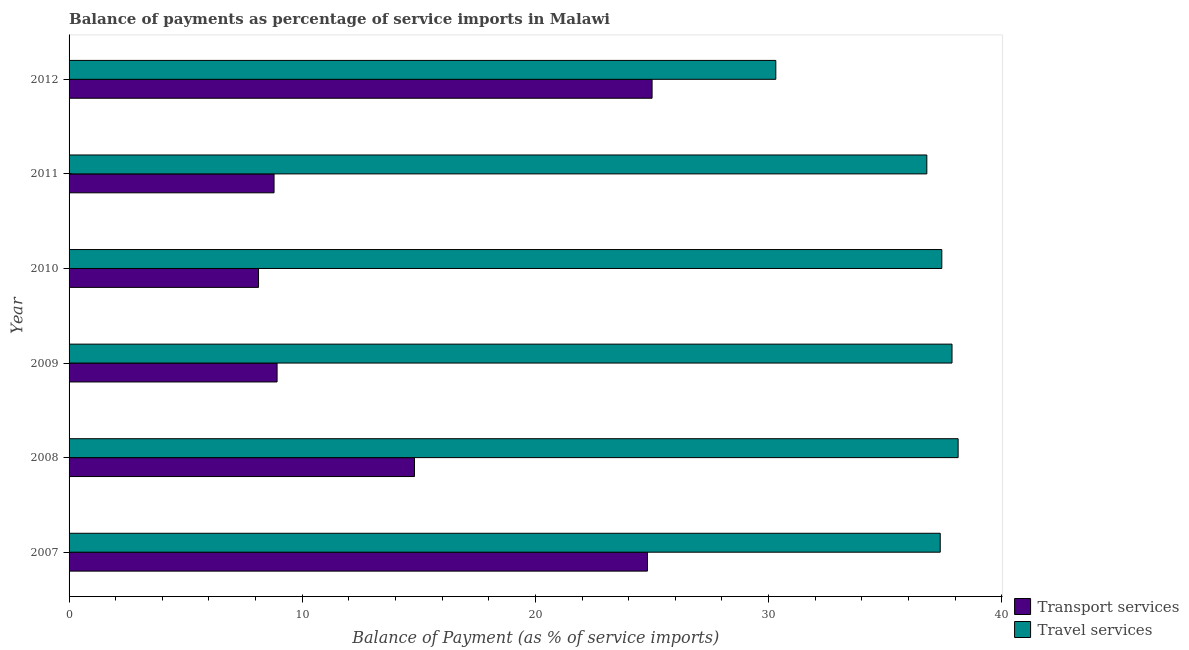How many groups of bars are there?
Your response must be concise. 6. Are the number of bars on each tick of the Y-axis equal?
Your answer should be compact. Yes. In how many cases, is the number of bars for a given year not equal to the number of legend labels?
Provide a short and direct response. 0. What is the balance of payments of transport services in 2011?
Your answer should be very brief. 8.79. Across all years, what is the maximum balance of payments of transport services?
Provide a short and direct response. 25. Across all years, what is the minimum balance of payments of transport services?
Offer a very short reply. 8.13. In which year was the balance of payments of travel services maximum?
Make the answer very short. 2008. In which year was the balance of payments of travel services minimum?
Your response must be concise. 2012. What is the total balance of payments of transport services in the graph?
Give a very brief answer. 90.46. What is the difference between the balance of payments of transport services in 2011 and the balance of payments of travel services in 2007?
Your answer should be very brief. -28.57. What is the average balance of payments of travel services per year?
Keep it short and to the point. 36.31. In the year 2010, what is the difference between the balance of payments of transport services and balance of payments of travel services?
Your answer should be very brief. -29.3. Is the difference between the balance of payments of travel services in 2008 and 2011 greater than the difference between the balance of payments of transport services in 2008 and 2011?
Provide a short and direct response. No. What is the difference between the highest and the second highest balance of payments of travel services?
Offer a very short reply. 0.26. What is the difference between the highest and the lowest balance of payments of transport services?
Provide a succinct answer. 16.88. In how many years, is the balance of payments of travel services greater than the average balance of payments of travel services taken over all years?
Keep it short and to the point. 5. Is the sum of the balance of payments of transport services in 2007 and 2010 greater than the maximum balance of payments of travel services across all years?
Provide a succinct answer. No. What does the 2nd bar from the top in 2009 represents?
Your response must be concise. Transport services. What does the 1st bar from the bottom in 2009 represents?
Your answer should be very brief. Transport services. What is the difference between two consecutive major ticks on the X-axis?
Provide a short and direct response. 10. Does the graph contain any zero values?
Provide a succinct answer. No. Where does the legend appear in the graph?
Your answer should be very brief. Bottom right. What is the title of the graph?
Provide a short and direct response. Balance of payments as percentage of service imports in Malawi. What is the label or title of the X-axis?
Provide a succinct answer. Balance of Payment (as % of service imports). What is the Balance of Payment (as % of service imports) of Transport services in 2007?
Make the answer very short. 24.81. What is the Balance of Payment (as % of service imports) in Travel services in 2007?
Your response must be concise. 37.36. What is the Balance of Payment (as % of service imports) in Transport services in 2008?
Your answer should be compact. 14.81. What is the Balance of Payment (as % of service imports) of Travel services in 2008?
Your answer should be compact. 38.13. What is the Balance of Payment (as % of service imports) in Transport services in 2009?
Offer a very short reply. 8.92. What is the Balance of Payment (as % of service imports) of Travel services in 2009?
Make the answer very short. 37.87. What is the Balance of Payment (as % of service imports) in Transport services in 2010?
Ensure brevity in your answer.  8.13. What is the Balance of Payment (as % of service imports) of Travel services in 2010?
Keep it short and to the point. 37.43. What is the Balance of Payment (as % of service imports) of Transport services in 2011?
Provide a succinct answer. 8.79. What is the Balance of Payment (as % of service imports) in Travel services in 2011?
Give a very brief answer. 36.79. What is the Balance of Payment (as % of service imports) in Transport services in 2012?
Make the answer very short. 25. What is the Balance of Payment (as % of service imports) in Travel services in 2012?
Your response must be concise. 30.31. Across all years, what is the maximum Balance of Payment (as % of service imports) of Transport services?
Ensure brevity in your answer.  25. Across all years, what is the maximum Balance of Payment (as % of service imports) in Travel services?
Offer a terse response. 38.13. Across all years, what is the minimum Balance of Payment (as % of service imports) in Transport services?
Give a very brief answer. 8.13. Across all years, what is the minimum Balance of Payment (as % of service imports) in Travel services?
Keep it short and to the point. 30.31. What is the total Balance of Payment (as % of service imports) in Transport services in the graph?
Offer a very short reply. 90.46. What is the total Balance of Payment (as % of service imports) of Travel services in the graph?
Give a very brief answer. 217.89. What is the difference between the Balance of Payment (as % of service imports) of Transport services in 2007 and that in 2008?
Your answer should be very brief. 9.99. What is the difference between the Balance of Payment (as % of service imports) of Travel services in 2007 and that in 2008?
Keep it short and to the point. -0.77. What is the difference between the Balance of Payment (as % of service imports) of Transport services in 2007 and that in 2009?
Offer a very short reply. 15.88. What is the difference between the Balance of Payment (as % of service imports) in Travel services in 2007 and that in 2009?
Your answer should be very brief. -0.51. What is the difference between the Balance of Payment (as % of service imports) in Transport services in 2007 and that in 2010?
Offer a very short reply. 16.68. What is the difference between the Balance of Payment (as % of service imports) of Travel services in 2007 and that in 2010?
Your answer should be very brief. -0.07. What is the difference between the Balance of Payment (as % of service imports) of Transport services in 2007 and that in 2011?
Offer a very short reply. 16.01. What is the difference between the Balance of Payment (as % of service imports) of Travel services in 2007 and that in 2011?
Provide a succinct answer. 0.58. What is the difference between the Balance of Payment (as % of service imports) of Transport services in 2007 and that in 2012?
Your answer should be compact. -0.2. What is the difference between the Balance of Payment (as % of service imports) in Travel services in 2007 and that in 2012?
Your response must be concise. 7.05. What is the difference between the Balance of Payment (as % of service imports) of Transport services in 2008 and that in 2009?
Provide a short and direct response. 5.89. What is the difference between the Balance of Payment (as % of service imports) of Travel services in 2008 and that in 2009?
Offer a terse response. 0.26. What is the difference between the Balance of Payment (as % of service imports) in Transport services in 2008 and that in 2010?
Ensure brevity in your answer.  6.69. What is the difference between the Balance of Payment (as % of service imports) of Travel services in 2008 and that in 2010?
Offer a very short reply. 0.7. What is the difference between the Balance of Payment (as % of service imports) of Transport services in 2008 and that in 2011?
Make the answer very short. 6.02. What is the difference between the Balance of Payment (as % of service imports) in Travel services in 2008 and that in 2011?
Give a very brief answer. 1.34. What is the difference between the Balance of Payment (as % of service imports) of Transport services in 2008 and that in 2012?
Your response must be concise. -10.19. What is the difference between the Balance of Payment (as % of service imports) of Travel services in 2008 and that in 2012?
Offer a terse response. 7.82. What is the difference between the Balance of Payment (as % of service imports) of Transport services in 2009 and that in 2010?
Provide a succinct answer. 0.8. What is the difference between the Balance of Payment (as % of service imports) of Travel services in 2009 and that in 2010?
Offer a very short reply. 0.44. What is the difference between the Balance of Payment (as % of service imports) of Transport services in 2009 and that in 2011?
Ensure brevity in your answer.  0.13. What is the difference between the Balance of Payment (as % of service imports) in Travel services in 2009 and that in 2011?
Offer a very short reply. 1.08. What is the difference between the Balance of Payment (as % of service imports) of Transport services in 2009 and that in 2012?
Make the answer very short. -16.08. What is the difference between the Balance of Payment (as % of service imports) of Travel services in 2009 and that in 2012?
Give a very brief answer. 7.56. What is the difference between the Balance of Payment (as % of service imports) of Transport services in 2010 and that in 2011?
Make the answer very short. -0.67. What is the difference between the Balance of Payment (as % of service imports) in Travel services in 2010 and that in 2011?
Your answer should be compact. 0.64. What is the difference between the Balance of Payment (as % of service imports) in Transport services in 2010 and that in 2012?
Keep it short and to the point. -16.88. What is the difference between the Balance of Payment (as % of service imports) in Travel services in 2010 and that in 2012?
Give a very brief answer. 7.12. What is the difference between the Balance of Payment (as % of service imports) of Transport services in 2011 and that in 2012?
Give a very brief answer. -16.21. What is the difference between the Balance of Payment (as % of service imports) of Travel services in 2011 and that in 2012?
Ensure brevity in your answer.  6.48. What is the difference between the Balance of Payment (as % of service imports) of Transport services in 2007 and the Balance of Payment (as % of service imports) of Travel services in 2008?
Offer a very short reply. -13.32. What is the difference between the Balance of Payment (as % of service imports) in Transport services in 2007 and the Balance of Payment (as % of service imports) in Travel services in 2009?
Provide a succinct answer. -13.06. What is the difference between the Balance of Payment (as % of service imports) in Transport services in 2007 and the Balance of Payment (as % of service imports) in Travel services in 2010?
Provide a succinct answer. -12.62. What is the difference between the Balance of Payment (as % of service imports) of Transport services in 2007 and the Balance of Payment (as % of service imports) of Travel services in 2011?
Offer a terse response. -11.98. What is the difference between the Balance of Payment (as % of service imports) in Transport services in 2007 and the Balance of Payment (as % of service imports) in Travel services in 2012?
Ensure brevity in your answer.  -5.51. What is the difference between the Balance of Payment (as % of service imports) in Transport services in 2008 and the Balance of Payment (as % of service imports) in Travel services in 2009?
Your response must be concise. -23.05. What is the difference between the Balance of Payment (as % of service imports) in Transport services in 2008 and the Balance of Payment (as % of service imports) in Travel services in 2010?
Keep it short and to the point. -22.62. What is the difference between the Balance of Payment (as % of service imports) in Transport services in 2008 and the Balance of Payment (as % of service imports) in Travel services in 2011?
Give a very brief answer. -21.97. What is the difference between the Balance of Payment (as % of service imports) of Transport services in 2008 and the Balance of Payment (as % of service imports) of Travel services in 2012?
Keep it short and to the point. -15.5. What is the difference between the Balance of Payment (as % of service imports) in Transport services in 2009 and the Balance of Payment (as % of service imports) in Travel services in 2010?
Provide a succinct answer. -28.51. What is the difference between the Balance of Payment (as % of service imports) in Transport services in 2009 and the Balance of Payment (as % of service imports) in Travel services in 2011?
Provide a succinct answer. -27.87. What is the difference between the Balance of Payment (as % of service imports) of Transport services in 2009 and the Balance of Payment (as % of service imports) of Travel services in 2012?
Offer a terse response. -21.39. What is the difference between the Balance of Payment (as % of service imports) of Transport services in 2010 and the Balance of Payment (as % of service imports) of Travel services in 2011?
Give a very brief answer. -28.66. What is the difference between the Balance of Payment (as % of service imports) in Transport services in 2010 and the Balance of Payment (as % of service imports) in Travel services in 2012?
Ensure brevity in your answer.  -22.19. What is the difference between the Balance of Payment (as % of service imports) of Transport services in 2011 and the Balance of Payment (as % of service imports) of Travel services in 2012?
Offer a terse response. -21.52. What is the average Balance of Payment (as % of service imports) in Transport services per year?
Offer a very short reply. 15.08. What is the average Balance of Payment (as % of service imports) of Travel services per year?
Give a very brief answer. 36.31. In the year 2007, what is the difference between the Balance of Payment (as % of service imports) of Transport services and Balance of Payment (as % of service imports) of Travel services?
Your answer should be very brief. -12.56. In the year 2008, what is the difference between the Balance of Payment (as % of service imports) in Transport services and Balance of Payment (as % of service imports) in Travel services?
Offer a terse response. -23.31. In the year 2009, what is the difference between the Balance of Payment (as % of service imports) of Transport services and Balance of Payment (as % of service imports) of Travel services?
Ensure brevity in your answer.  -28.95. In the year 2010, what is the difference between the Balance of Payment (as % of service imports) of Transport services and Balance of Payment (as % of service imports) of Travel services?
Offer a terse response. -29.3. In the year 2011, what is the difference between the Balance of Payment (as % of service imports) of Transport services and Balance of Payment (as % of service imports) of Travel services?
Your answer should be very brief. -28. In the year 2012, what is the difference between the Balance of Payment (as % of service imports) of Transport services and Balance of Payment (as % of service imports) of Travel services?
Provide a succinct answer. -5.31. What is the ratio of the Balance of Payment (as % of service imports) in Transport services in 2007 to that in 2008?
Your answer should be compact. 1.67. What is the ratio of the Balance of Payment (as % of service imports) of Travel services in 2007 to that in 2008?
Make the answer very short. 0.98. What is the ratio of the Balance of Payment (as % of service imports) of Transport services in 2007 to that in 2009?
Your response must be concise. 2.78. What is the ratio of the Balance of Payment (as % of service imports) in Travel services in 2007 to that in 2009?
Your answer should be compact. 0.99. What is the ratio of the Balance of Payment (as % of service imports) in Transport services in 2007 to that in 2010?
Your answer should be very brief. 3.05. What is the ratio of the Balance of Payment (as % of service imports) of Travel services in 2007 to that in 2010?
Offer a terse response. 1. What is the ratio of the Balance of Payment (as % of service imports) of Transport services in 2007 to that in 2011?
Offer a very short reply. 2.82. What is the ratio of the Balance of Payment (as % of service imports) in Travel services in 2007 to that in 2011?
Make the answer very short. 1.02. What is the ratio of the Balance of Payment (as % of service imports) of Transport services in 2007 to that in 2012?
Provide a short and direct response. 0.99. What is the ratio of the Balance of Payment (as % of service imports) in Travel services in 2007 to that in 2012?
Your answer should be compact. 1.23. What is the ratio of the Balance of Payment (as % of service imports) in Transport services in 2008 to that in 2009?
Make the answer very short. 1.66. What is the ratio of the Balance of Payment (as % of service imports) of Transport services in 2008 to that in 2010?
Your answer should be very brief. 1.82. What is the ratio of the Balance of Payment (as % of service imports) in Travel services in 2008 to that in 2010?
Offer a very short reply. 1.02. What is the ratio of the Balance of Payment (as % of service imports) in Transport services in 2008 to that in 2011?
Offer a terse response. 1.69. What is the ratio of the Balance of Payment (as % of service imports) of Travel services in 2008 to that in 2011?
Make the answer very short. 1.04. What is the ratio of the Balance of Payment (as % of service imports) of Transport services in 2008 to that in 2012?
Keep it short and to the point. 0.59. What is the ratio of the Balance of Payment (as % of service imports) of Travel services in 2008 to that in 2012?
Offer a very short reply. 1.26. What is the ratio of the Balance of Payment (as % of service imports) of Transport services in 2009 to that in 2010?
Provide a short and direct response. 1.1. What is the ratio of the Balance of Payment (as % of service imports) in Travel services in 2009 to that in 2010?
Ensure brevity in your answer.  1.01. What is the ratio of the Balance of Payment (as % of service imports) of Transport services in 2009 to that in 2011?
Offer a terse response. 1.01. What is the ratio of the Balance of Payment (as % of service imports) of Travel services in 2009 to that in 2011?
Make the answer very short. 1.03. What is the ratio of the Balance of Payment (as % of service imports) in Transport services in 2009 to that in 2012?
Make the answer very short. 0.36. What is the ratio of the Balance of Payment (as % of service imports) in Travel services in 2009 to that in 2012?
Your answer should be compact. 1.25. What is the ratio of the Balance of Payment (as % of service imports) in Transport services in 2010 to that in 2011?
Provide a short and direct response. 0.92. What is the ratio of the Balance of Payment (as % of service imports) in Travel services in 2010 to that in 2011?
Keep it short and to the point. 1.02. What is the ratio of the Balance of Payment (as % of service imports) of Transport services in 2010 to that in 2012?
Provide a short and direct response. 0.33. What is the ratio of the Balance of Payment (as % of service imports) of Travel services in 2010 to that in 2012?
Give a very brief answer. 1.23. What is the ratio of the Balance of Payment (as % of service imports) in Transport services in 2011 to that in 2012?
Offer a terse response. 0.35. What is the ratio of the Balance of Payment (as % of service imports) of Travel services in 2011 to that in 2012?
Provide a succinct answer. 1.21. What is the difference between the highest and the second highest Balance of Payment (as % of service imports) in Transport services?
Your response must be concise. 0.2. What is the difference between the highest and the second highest Balance of Payment (as % of service imports) in Travel services?
Offer a terse response. 0.26. What is the difference between the highest and the lowest Balance of Payment (as % of service imports) in Transport services?
Make the answer very short. 16.88. What is the difference between the highest and the lowest Balance of Payment (as % of service imports) in Travel services?
Make the answer very short. 7.82. 